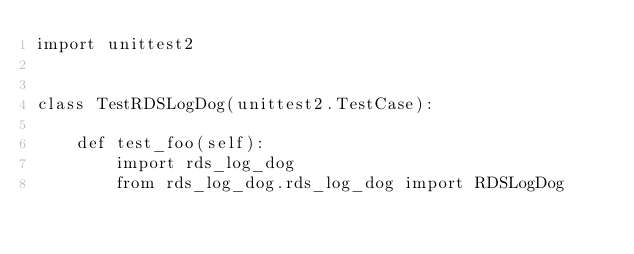<code> <loc_0><loc_0><loc_500><loc_500><_Python_>import unittest2


class TestRDSLogDog(unittest2.TestCase):

    def test_foo(self):
        import rds_log_dog
        from rds_log_dog.rds_log_dog import RDSLogDog
</code> 